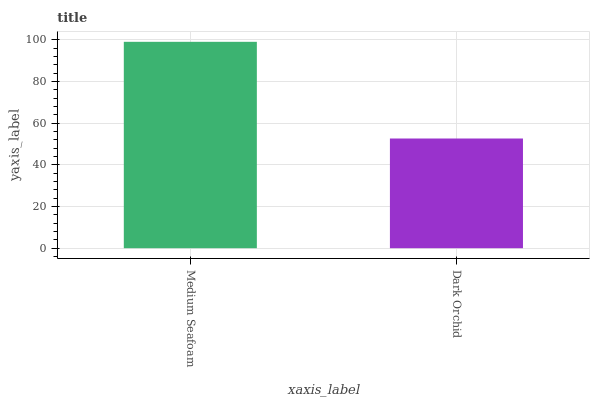Is Dark Orchid the minimum?
Answer yes or no. Yes. Is Medium Seafoam the maximum?
Answer yes or no. Yes. Is Dark Orchid the maximum?
Answer yes or no. No. Is Medium Seafoam greater than Dark Orchid?
Answer yes or no. Yes. Is Dark Orchid less than Medium Seafoam?
Answer yes or no. Yes. Is Dark Orchid greater than Medium Seafoam?
Answer yes or no. No. Is Medium Seafoam less than Dark Orchid?
Answer yes or no. No. Is Medium Seafoam the high median?
Answer yes or no. Yes. Is Dark Orchid the low median?
Answer yes or no. Yes. Is Dark Orchid the high median?
Answer yes or no. No. Is Medium Seafoam the low median?
Answer yes or no. No. 